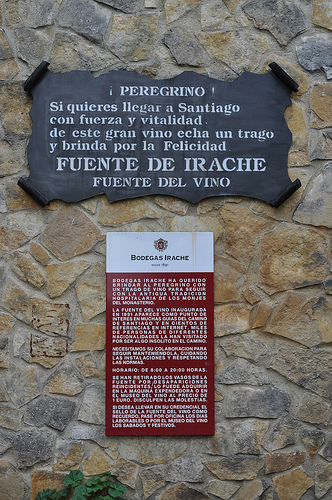<image>
Can you confirm if the sign is next to the wall? No. The sign is not positioned next to the wall. They are located in different areas of the scene. 